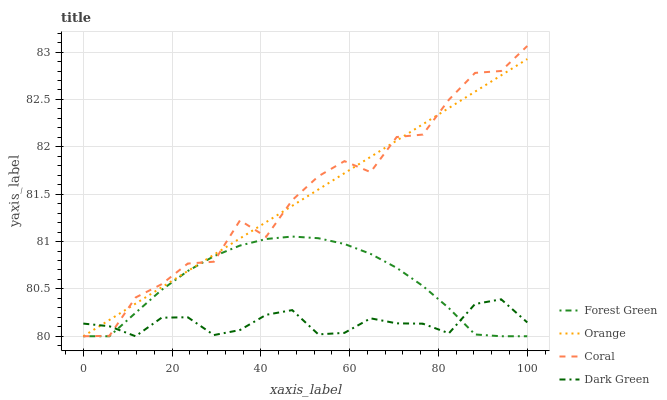Does Dark Green have the minimum area under the curve?
Answer yes or no. Yes. Does Coral have the maximum area under the curve?
Answer yes or no. Yes. Does Forest Green have the minimum area under the curve?
Answer yes or no. No. Does Forest Green have the maximum area under the curve?
Answer yes or no. No. Is Orange the smoothest?
Answer yes or no. Yes. Is Coral the roughest?
Answer yes or no. Yes. Is Forest Green the smoothest?
Answer yes or no. No. Is Forest Green the roughest?
Answer yes or no. No. Does Orange have the lowest value?
Answer yes or no. Yes. Does Coral have the highest value?
Answer yes or no. Yes. Does Forest Green have the highest value?
Answer yes or no. No. Does Dark Green intersect Forest Green?
Answer yes or no. Yes. Is Dark Green less than Forest Green?
Answer yes or no. No. Is Dark Green greater than Forest Green?
Answer yes or no. No. 